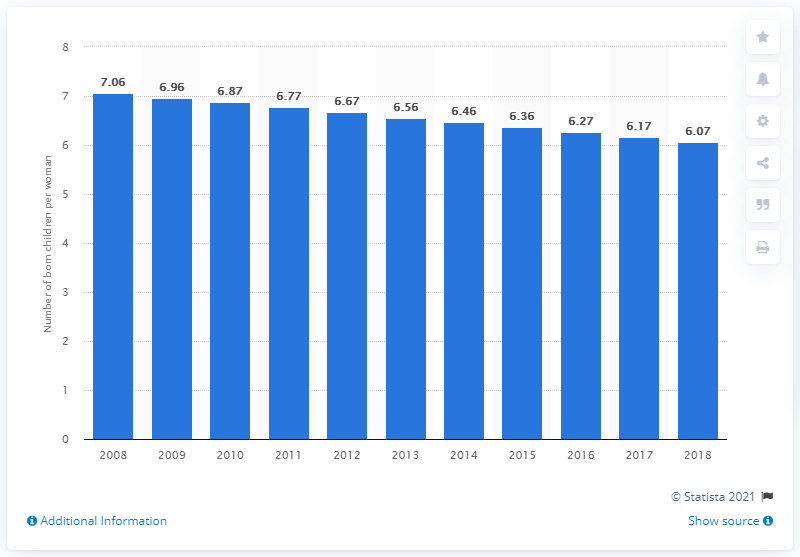Mention a couple of crucial points in this snapshot. In 2018, Somalia's fertility rate was 6.07. 